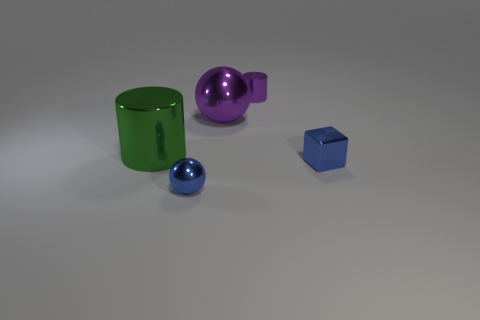Do the shiny ball that is on the right side of the tiny blue shiny sphere and the tiny metallic object on the left side of the purple cylinder have the same color?
Your answer should be very brief. No. Is the number of big green objects that are behind the tiny metallic cylinder less than the number of tiny spheres that are to the right of the metallic block?
Ensure brevity in your answer.  No. There is a purple metal thing left of the tiny metallic cylinder; what is its shape?
Offer a very short reply. Sphere. What is the material of the cylinder that is the same color as the large shiny sphere?
Ensure brevity in your answer.  Metal. How many other things are the same material as the small blue ball?
Make the answer very short. 4. Does the tiny purple metallic thing have the same shape as the large thing that is right of the green thing?
Offer a terse response. No. What is the shape of the small purple thing that is made of the same material as the green cylinder?
Keep it short and to the point. Cylinder. Is the number of blue metal blocks that are right of the green thing greater than the number of blue metallic objects that are behind the purple cylinder?
Your response must be concise. Yes. How many objects are either tiny shiny cubes or tiny cyan cylinders?
Your answer should be very brief. 1. How many other objects are there of the same color as the small cylinder?
Make the answer very short. 1. 